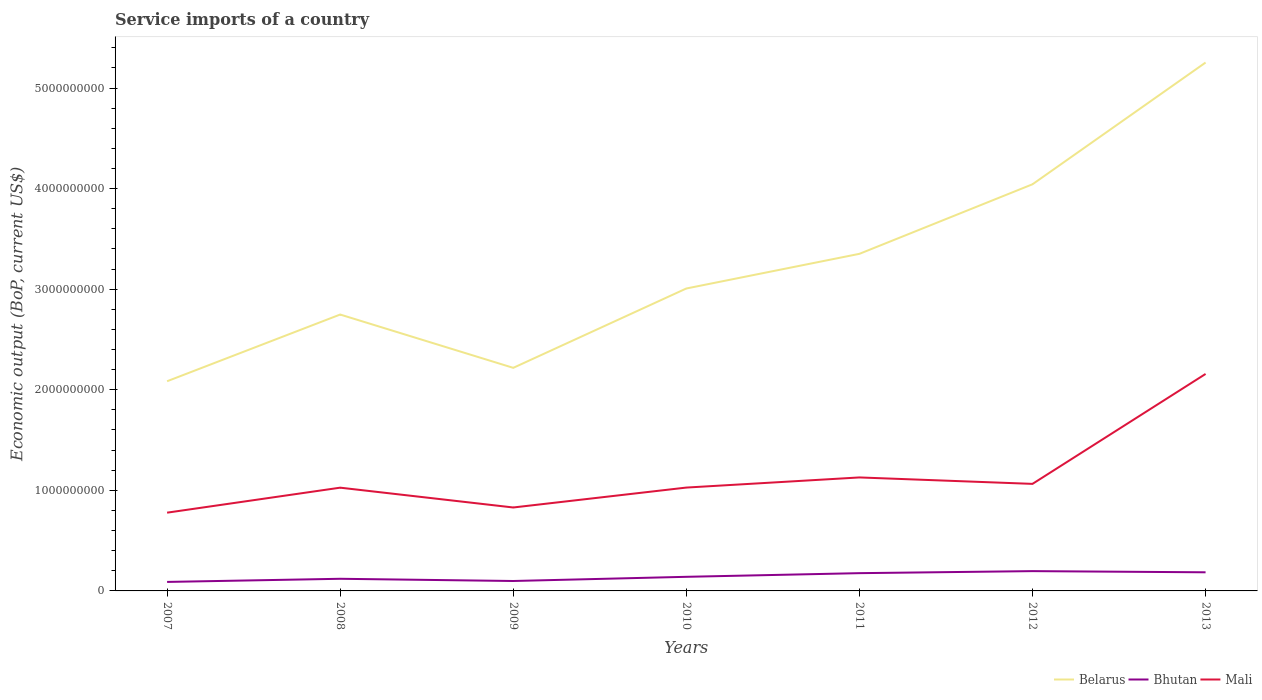Across all years, what is the maximum service imports in Belarus?
Your answer should be very brief. 2.08e+09. In which year was the service imports in Mali maximum?
Your answer should be very brief. 2007. What is the total service imports in Mali in the graph?
Provide a succinct answer. -1.13e+09. What is the difference between the highest and the second highest service imports in Bhutan?
Provide a short and direct response. 1.07e+08. What is the difference between the highest and the lowest service imports in Bhutan?
Ensure brevity in your answer.  3. Is the service imports in Mali strictly greater than the service imports in Bhutan over the years?
Keep it short and to the point. No. Are the values on the major ticks of Y-axis written in scientific E-notation?
Make the answer very short. No. Does the graph contain grids?
Provide a short and direct response. No. Where does the legend appear in the graph?
Ensure brevity in your answer.  Bottom right. How many legend labels are there?
Your answer should be very brief. 3. What is the title of the graph?
Provide a succinct answer. Service imports of a country. Does "Sub-Saharan Africa (all income levels)" appear as one of the legend labels in the graph?
Offer a terse response. No. What is the label or title of the X-axis?
Your answer should be very brief. Years. What is the label or title of the Y-axis?
Make the answer very short. Economic output (BoP, current US$). What is the Economic output (BoP, current US$) in Belarus in 2007?
Keep it short and to the point. 2.08e+09. What is the Economic output (BoP, current US$) of Bhutan in 2007?
Your response must be concise. 8.94e+07. What is the Economic output (BoP, current US$) in Mali in 2007?
Provide a succinct answer. 7.78e+08. What is the Economic output (BoP, current US$) in Belarus in 2008?
Make the answer very short. 2.75e+09. What is the Economic output (BoP, current US$) of Bhutan in 2008?
Provide a short and direct response. 1.21e+08. What is the Economic output (BoP, current US$) of Mali in 2008?
Make the answer very short. 1.03e+09. What is the Economic output (BoP, current US$) in Belarus in 2009?
Make the answer very short. 2.22e+09. What is the Economic output (BoP, current US$) in Bhutan in 2009?
Make the answer very short. 9.87e+07. What is the Economic output (BoP, current US$) of Mali in 2009?
Provide a short and direct response. 8.30e+08. What is the Economic output (BoP, current US$) in Belarus in 2010?
Offer a terse response. 3.01e+09. What is the Economic output (BoP, current US$) in Bhutan in 2010?
Your answer should be compact. 1.40e+08. What is the Economic output (BoP, current US$) in Mali in 2010?
Your answer should be compact. 1.03e+09. What is the Economic output (BoP, current US$) of Belarus in 2011?
Offer a terse response. 3.35e+09. What is the Economic output (BoP, current US$) of Bhutan in 2011?
Provide a short and direct response. 1.77e+08. What is the Economic output (BoP, current US$) in Mali in 2011?
Your answer should be very brief. 1.13e+09. What is the Economic output (BoP, current US$) in Belarus in 2012?
Provide a succinct answer. 4.04e+09. What is the Economic output (BoP, current US$) in Bhutan in 2012?
Keep it short and to the point. 1.97e+08. What is the Economic output (BoP, current US$) of Mali in 2012?
Keep it short and to the point. 1.06e+09. What is the Economic output (BoP, current US$) in Belarus in 2013?
Provide a short and direct response. 5.25e+09. What is the Economic output (BoP, current US$) in Bhutan in 2013?
Give a very brief answer. 1.85e+08. What is the Economic output (BoP, current US$) of Mali in 2013?
Your response must be concise. 2.16e+09. Across all years, what is the maximum Economic output (BoP, current US$) in Belarus?
Offer a very short reply. 5.25e+09. Across all years, what is the maximum Economic output (BoP, current US$) in Bhutan?
Your response must be concise. 1.97e+08. Across all years, what is the maximum Economic output (BoP, current US$) in Mali?
Keep it short and to the point. 2.16e+09. Across all years, what is the minimum Economic output (BoP, current US$) in Belarus?
Your answer should be very brief. 2.08e+09. Across all years, what is the minimum Economic output (BoP, current US$) of Bhutan?
Provide a short and direct response. 8.94e+07. Across all years, what is the minimum Economic output (BoP, current US$) of Mali?
Give a very brief answer. 7.78e+08. What is the total Economic output (BoP, current US$) of Belarus in the graph?
Offer a terse response. 2.27e+1. What is the total Economic output (BoP, current US$) in Bhutan in the graph?
Your answer should be very brief. 1.01e+09. What is the total Economic output (BoP, current US$) in Mali in the graph?
Offer a terse response. 8.01e+09. What is the difference between the Economic output (BoP, current US$) of Belarus in 2007 and that in 2008?
Your response must be concise. -6.63e+08. What is the difference between the Economic output (BoP, current US$) in Bhutan in 2007 and that in 2008?
Your response must be concise. -3.13e+07. What is the difference between the Economic output (BoP, current US$) in Mali in 2007 and that in 2008?
Ensure brevity in your answer.  -2.48e+08. What is the difference between the Economic output (BoP, current US$) in Belarus in 2007 and that in 2009?
Provide a succinct answer. -1.33e+08. What is the difference between the Economic output (BoP, current US$) in Bhutan in 2007 and that in 2009?
Make the answer very short. -9.28e+06. What is the difference between the Economic output (BoP, current US$) of Mali in 2007 and that in 2009?
Offer a terse response. -5.15e+07. What is the difference between the Economic output (BoP, current US$) in Belarus in 2007 and that in 2010?
Provide a short and direct response. -9.22e+08. What is the difference between the Economic output (BoP, current US$) of Bhutan in 2007 and that in 2010?
Offer a terse response. -5.08e+07. What is the difference between the Economic output (BoP, current US$) of Mali in 2007 and that in 2010?
Ensure brevity in your answer.  -2.49e+08. What is the difference between the Economic output (BoP, current US$) of Belarus in 2007 and that in 2011?
Provide a short and direct response. -1.27e+09. What is the difference between the Economic output (BoP, current US$) in Bhutan in 2007 and that in 2011?
Provide a succinct answer. -8.71e+07. What is the difference between the Economic output (BoP, current US$) of Mali in 2007 and that in 2011?
Your answer should be very brief. -3.50e+08. What is the difference between the Economic output (BoP, current US$) in Belarus in 2007 and that in 2012?
Give a very brief answer. -1.96e+09. What is the difference between the Economic output (BoP, current US$) of Bhutan in 2007 and that in 2012?
Your answer should be compact. -1.07e+08. What is the difference between the Economic output (BoP, current US$) in Mali in 2007 and that in 2012?
Give a very brief answer. -2.86e+08. What is the difference between the Economic output (BoP, current US$) of Belarus in 2007 and that in 2013?
Your answer should be compact. -3.17e+09. What is the difference between the Economic output (BoP, current US$) in Bhutan in 2007 and that in 2013?
Make the answer very short. -9.58e+07. What is the difference between the Economic output (BoP, current US$) of Mali in 2007 and that in 2013?
Offer a very short reply. -1.38e+09. What is the difference between the Economic output (BoP, current US$) in Belarus in 2008 and that in 2009?
Offer a terse response. 5.30e+08. What is the difference between the Economic output (BoP, current US$) in Bhutan in 2008 and that in 2009?
Your answer should be compact. 2.20e+07. What is the difference between the Economic output (BoP, current US$) of Mali in 2008 and that in 2009?
Keep it short and to the point. 1.97e+08. What is the difference between the Economic output (BoP, current US$) of Belarus in 2008 and that in 2010?
Provide a succinct answer. -2.59e+08. What is the difference between the Economic output (BoP, current US$) in Bhutan in 2008 and that in 2010?
Provide a succinct answer. -1.95e+07. What is the difference between the Economic output (BoP, current US$) in Mali in 2008 and that in 2010?
Your response must be concise. -1.00e+06. What is the difference between the Economic output (BoP, current US$) of Belarus in 2008 and that in 2011?
Provide a succinct answer. -6.04e+08. What is the difference between the Economic output (BoP, current US$) of Bhutan in 2008 and that in 2011?
Make the answer very short. -5.59e+07. What is the difference between the Economic output (BoP, current US$) in Mali in 2008 and that in 2011?
Your response must be concise. -1.02e+08. What is the difference between the Economic output (BoP, current US$) in Belarus in 2008 and that in 2012?
Provide a succinct answer. -1.30e+09. What is the difference between the Economic output (BoP, current US$) of Bhutan in 2008 and that in 2012?
Your response must be concise. -7.62e+07. What is the difference between the Economic output (BoP, current US$) of Mali in 2008 and that in 2012?
Provide a short and direct response. -3.77e+07. What is the difference between the Economic output (BoP, current US$) in Belarus in 2008 and that in 2013?
Your response must be concise. -2.51e+09. What is the difference between the Economic output (BoP, current US$) of Bhutan in 2008 and that in 2013?
Give a very brief answer. -6.46e+07. What is the difference between the Economic output (BoP, current US$) of Mali in 2008 and that in 2013?
Your answer should be compact. -1.13e+09. What is the difference between the Economic output (BoP, current US$) of Belarus in 2009 and that in 2010?
Provide a short and direct response. -7.89e+08. What is the difference between the Economic output (BoP, current US$) of Bhutan in 2009 and that in 2010?
Your response must be concise. -4.15e+07. What is the difference between the Economic output (BoP, current US$) in Mali in 2009 and that in 2010?
Offer a very short reply. -1.98e+08. What is the difference between the Economic output (BoP, current US$) in Belarus in 2009 and that in 2011?
Provide a succinct answer. -1.13e+09. What is the difference between the Economic output (BoP, current US$) in Bhutan in 2009 and that in 2011?
Ensure brevity in your answer.  -7.79e+07. What is the difference between the Economic output (BoP, current US$) of Mali in 2009 and that in 2011?
Give a very brief answer. -2.99e+08. What is the difference between the Economic output (BoP, current US$) of Belarus in 2009 and that in 2012?
Offer a terse response. -1.83e+09. What is the difference between the Economic output (BoP, current US$) in Bhutan in 2009 and that in 2012?
Offer a terse response. -9.82e+07. What is the difference between the Economic output (BoP, current US$) of Mali in 2009 and that in 2012?
Ensure brevity in your answer.  -2.35e+08. What is the difference between the Economic output (BoP, current US$) in Belarus in 2009 and that in 2013?
Offer a very short reply. -3.04e+09. What is the difference between the Economic output (BoP, current US$) in Bhutan in 2009 and that in 2013?
Offer a terse response. -8.65e+07. What is the difference between the Economic output (BoP, current US$) in Mali in 2009 and that in 2013?
Ensure brevity in your answer.  -1.33e+09. What is the difference between the Economic output (BoP, current US$) in Belarus in 2010 and that in 2011?
Provide a succinct answer. -3.45e+08. What is the difference between the Economic output (BoP, current US$) of Bhutan in 2010 and that in 2011?
Make the answer very short. -3.64e+07. What is the difference between the Economic output (BoP, current US$) in Mali in 2010 and that in 2011?
Your answer should be very brief. -1.01e+08. What is the difference between the Economic output (BoP, current US$) of Belarus in 2010 and that in 2012?
Your answer should be very brief. -1.04e+09. What is the difference between the Economic output (BoP, current US$) of Bhutan in 2010 and that in 2012?
Your response must be concise. -5.67e+07. What is the difference between the Economic output (BoP, current US$) of Mali in 2010 and that in 2012?
Provide a short and direct response. -3.67e+07. What is the difference between the Economic output (BoP, current US$) in Belarus in 2010 and that in 2013?
Give a very brief answer. -2.25e+09. What is the difference between the Economic output (BoP, current US$) in Bhutan in 2010 and that in 2013?
Provide a short and direct response. -4.50e+07. What is the difference between the Economic output (BoP, current US$) of Mali in 2010 and that in 2013?
Your response must be concise. -1.13e+09. What is the difference between the Economic output (BoP, current US$) of Belarus in 2011 and that in 2012?
Your response must be concise. -6.92e+08. What is the difference between the Economic output (BoP, current US$) in Bhutan in 2011 and that in 2012?
Make the answer very short. -2.03e+07. What is the difference between the Economic output (BoP, current US$) of Mali in 2011 and that in 2012?
Your answer should be very brief. 6.41e+07. What is the difference between the Economic output (BoP, current US$) of Belarus in 2011 and that in 2013?
Make the answer very short. -1.90e+09. What is the difference between the Economic output (BoP, current US$) in Bhutan in 2011 and that in 2013?
Ensure brevity in your answer.  -8.68e+06. What is the difference between the Economic output (BoP, current US$) of Mali in 2011 and that in 2013?
Ensure brevity in your answer.  -1.03e+09. What is the difference between the Economic output (BoP, current US$) in Belarus in 2012 and that in 2013?
Ensure brevity in your answer.  -1.21e+09. What is the difference between the Economic output (BoP, current US$) in Bhutan in 2012 and that in 2013?
Keep it short and to the point. 1.16e+07. What is the difference between the Economic output (BoP, current US$) of Mali in 2012 and that in 2013?
Ensure brevity in your answer.  -1.09e+09. What is the difference between the Economic output (BoP, current US$) of Belarus in 2007 and the Economic output (BoP, current US$) of Bhutan in 2008?
Give a very brief answer. 1.96e+09. What is the difference between the Economic output (BoP, current US$) in Belarus in 2007 and the Economic output (BoP, current US$) in Mali in 2008?
Ensure brevity in your answer.  1.06e+09. What is the difference between the Economic output (BoP, current US$) of Bhutan in 2007 and the Economic output (BoP, current US$) of Mali in 2008?
Your answer should be very brief. -9.37e+08. What is the difference between the Economic output (BoP, current US$) of Belarus in 2007 and the Economic output (BoP, current US$) of Bhutan in 2009?
Offer a terse response. 1.99e+09. What is the difference between the Economic output (BoP, current US$) of Belarus in 2007 and the Economic output (BoP, current US$) of Mali in 2009?
Give a very brief answer. 1.26e+09. What is the difference between the Economic output (BoP, current US$) of Bhutan in 2007 and the Economic output (BoP, current US$) of Mali in 2009?
Provide a short and direct response. -7.40e+08. What is the difference between the Economic output (BoP, current US$) in Belarus in 2007 and the Economic output (BoP, current US$) in Bhutan in 2010?
Your answer should be compact. 1.94e+09. What is the difference between the Economic output (BoP, current US$) in Belarus in 2007 and the Economic output (BoP, current US$) in Mali in 2010?
Offer a very short reply. 1.06e+09. What is the difference between the Economic output (BoP, current US$) in Bhutan in 2007 and the Economic output (BoP, current US$) in Mali in 2010?
Your response must be concise. -9.38e+08. What is the difference between the Economic output (BoP, current US$) in Belarus in 2007 and the Economic output (BoP, current US$) in Bhutan in 2011?
Ensure brevity in your answer.  1.91e+09. What is the difference between the Economic output (BoP, current US$) in Belarus in 2007 and the Economic output (BoP, current US$) in Mali in 2011?
Your answer should be compact. 9.56e+08. What is the difference between the Economic output (BoP, current US$) in Bhutan in 2007 and the Economic output (BoP, current US$) in Mali in 2011?
Make the answer very short. -1.04e+09. What is the difference between the Economic output (BoP, current US$) of Belarus in 2007 and the Economic output (BoP, current US$) of Bhutan in 2012?
Ensure brevity in your answer.  1.89e+09. What is the difference between the Economic output (BoP, current US$) in Belarus in 2007 and the Economic output (BoP, current US$) in Mali in 2012?
Offer a very short reply. 1.02e+09. What is the difference between the Economic output (BoP, current US$) in Bhutan in 2007 and the Economic output (BoP, current US$) in Mali in 2012?
Ensure brevity in your answer.  -9.75e+08. What is the difference between the Economic output (BoP, current US$) in Belarus in 2007 and the Economic output (BoP, current US$) in Bhutan in 2013?
Your answer should be compact. 1.90e+09. What is the difference between the Economic output (BoP, current US$) of Belarus in 2007 and the Economic output (BoP, current US$) of Mali in 2013?
Provide a short and direct response. -7.26e+07. What is the difference between the Economic output (BoP, current US$) of Bhutan in 2007 and the Economic output (BoP, current US$) of Mali in 2013?
Provide a succinct answer. -2.07e+09. What is the difference between the Economic output (BoP, current US$) of Belarus in 2008 and the Economic output (BoP, current US$) of Bhutan in 2009?
Give a very brief answer. 2.65e+09. What is the difference between the Economic output (BoP, current US$) of Belarus in 2008 and the Economic output (BoP, current US$) of Mali in 2009?
Your answer should be compact. 1.92e+09. What is the difference between the Economic output (BoP, current US$) of Bhutan in 2008 and the Economic output (BoP, current US$) of Mali in 2009?
Provide a succinct answer. -7.09e+08. What is the difference between the Economic output (BoP, current US$) of Belarus in 2008 and the Economic output (BoP, current US$) of Bhutan in 2010?
Your answer should be compact. 2.61e+09. What is the difference between the Economic output (BoP, current US$) of Belarus in 2008 and the Economic output (BoP, current US$) of Mali in 2010?
Ensure brevity in your answer.  1.72e+09. What is the difference between the Economic output (BoP, current US$) of Bhutan in 2008 and the Economic output (BoP, current US$) of Mali in 2010?
Make the answer very short. -9.07e+08. What is the difference between the Economic output (BoP, current US$) in Belarus in 2008 and the Economic output (BoP, current US$) in Bhutan in 2011?
Offer a terse response. 2.57e+09. What is the difference between the Economic output (BoP, current US$) in Belarus in 2008 and the Economic output (BoP, current US$) in Mali in 2011?
Ensure brevity in your answer.  1.62e+09. What is the difference between the Economic output (BoP, current US$) in Bhutan in 2008 and the Economic output (BoP, current US$) in Mali in 2011?
Offer a terse response. -1.01e+09. What is the difference between the Economic output (BoP, current US$) of Belarus in 2008 and the Economic output (BoP, current US$) of Bhutan in 2012?
Your response must be concise. 2.55e+09. What is the difference between the Economic output (BoP, current US$) in Belarus in 2008 and the Economic output (BoP, current US$) in Mali in 2012?
Provide a short and direct response. 1.68e+09. What is the difference between the Economic output (BoP, current US$) in Bhutan in 2008 and the Economic output (BoP, current US$) in Mali in 2012?
Give a very brief answer. -9.44e+08. What is the difference between the Economic output (BoP, current US$) in Belarus in 2008 and the Economic output (BoP, current US$) in Bhutan in 2013?
Keep it short and to the point. 2.56e+09. What is the difference between the Economic output (BoP, current US$) of Belarus in 2008 and the Economic output (BoP, current US$) of Mali in 2013?
Make the answer very short. 5.91e+08. What is the difference between the Economic output (BoP, current US$) of Bhutan in 2008 and the Economic output (BoP, current US$) of Mali in 2013?
Offer a very short reply. -2.04e+09. What is the difference between the Economic output (BoP, current US$) of Belarus in 2009 and the Economic output (BoP, current US$) of Bhutan in 2010?
Your answer should be compact. 2.08e+09. What is the difference between the Economic output (BoP, current US$) of Belarus in 2009 and the Economic output (BoP, current US$) of Mali in 2010?
Your answer should be very brief. 1.19e+09. What is the difference between the Economic output (BoP, current US$) of Bhutan in 2009 and the Economic output (BoP, current US$) of Mali in 2010?
Give a very brief answer. -9.29e+08. What is the difference between the Economic output (BoP, current US$) in Belarus in 2009 and the Economic output (BoP, current US$) in Bhutan in 2011?
Ensure brevity in your answer.  2.04e+09. What is the difference between the Economic output (BoP, current US$) of Belarus in 2009 and the Economic output (BoP, current US$) of Mali in 2011?
Provide a succinct answer. 1.09e+09. What is the difference between the Economic output (BoP, current US$) in Bhutan in 2009 and the Economic output (BoP, current US$) in Mali in 2011?
Offer a very short reply. -1.03e+09. What is the difference between the Economic output (BoP, current US$) in Belarus in 2009 and the Economic output (BoP, current US$) in Bhutan in 2012?
Offer a very short reply. 2.02e+09. What is the difference between the Economic output (BoP, current US$) in Belarus in 2009 and the Economic output (BoP, current US$) in Mali in 2012?
Your answer should be very brief. 1.15e+09. What is the difference between the Economic output (BoP, current US$) of Bhutan in 2009 and the Economic output (BoP, current US$) of Mali in 2012?
Offer a very short reply. -9.66e+08. What is the difference between the Economic output (BoP, current US$) of Belarus in 2009 and the Economic output (BoP, current US$) of Bhutan in 2013?
Provide a succinct answer. 2.03e+09. What is the difference between the Economic output (BoP, current US$) of Belarus in 2009 and the Economic output (BoP, current US$) of Mali in 2013?
Offer a terse response. 6.06e+07. What is the difference between the Economic output (BoP, current US$) in Bhutan in 2009 and the Economic output (BoP, current US$) in Mali in 2013?
Your answer should be compact. -2.06e+09. What is the difference between the Economic output (BoP, current US$) of Belarus in 2010 and the Economic output (BoP, current US$) of Bhutan in 2011?
Give a very brief answer. 2.83e+09. What is the difference between the Economic output (BoP, current US$) in Belarus in 2010 and the Economic output (BoP, current US$) in Mali in 2011?
Offer a very short reply. 1.88e+09. What is the difference between the Economic output (BoP, current US$) in Bhutan in 2010 and the Economic output (BoP, current US$) in Mali in 2011?
Provide a short and direct response. -9.88e+08. What is the difference between the Economic output (BoP, current US$) in Belarus in 2010 and the Economic output (BoP, current US$) in Bhutan in 2012?
Offer a very short reply. 2.81e+09. What is the difference between the Economic output (BoP, current US$) in Belarus in 2010 and the Economic output (BoP, current US$) in Mali in 2012?
Your answer should be compact. 1.94e+09. What is the difference between the Economic output (BoP, current US$) in Bhutan in 2010 and the Economic output (BoP, current US$) in Mali in 2012?
Give a very brief answer. -9.24e+08. What is the difference between the Economic output (BoP, current US$) in Belarus in 2010 and the Economic output (BoP, current US$) in Bhutan in 2013?
Offer a very short reply. 2.82e+09. What is the difference between the Economic output (BoP, current US$) in Belarus in 2010 and the Economic output (BoP, current US$) in Mali in 2013?
Your response must be concise. 8.50e+08. What is the difference between the Economic output (BoP, current US$) of Bhutan in 2010 and the Economic output (BoP, current US$) of Mali in 2013?
Offer a very short reply. -2.02e+09. What is the difference between the Economic output (BoP, current US$) in Belarus in 2011 and the Economic output (BoP, current US$) in Bhutan in 2012?
Provide a short and direct response. 3.15e+09. What is the difference between the Economic output (BoP, current US$) of Belarus in 2011 and the Economic output (BoP, current US$) of Mali in 2012?
Keep it short and to the point. 2.29e+09. What is the difference between the Economic output (BoP, current US$) of Bhutan in 2011 and the Economic output (BoP, current US$) of Mali in 2012?
Offer a terse response. -8.88e+08. What is the difference between the Economic output (BoP, current US$) in Belarus in 2011 and the Economic output (BoP, current US$) in Bhutan in 2013?
Offer a terse response. 3.17e+09. What is the difference between the Economic output (BoP, current US$) in Belarus in 2011 and the Economic output (BoP, current US$) in Mali in 2013?
Provide a succinct answer. 1.19e+09. What is the difference between the Economic output (BoP, current US$) in Bhutan in 2011 and the Economic output (BoP, current US$) in Mali in 2013?
Provide a succinct answer. -1.98e+09. What is the difference between the Economic output (BoP, current US$) in Belarus in 2012 and the Economic output (BoP, current US$) in Bhutan in 2013?
Offer a terse response. 3.86e+09. What is the difference between the Economic output (BoP, current US$) in Belarus in 2012 and the Economic output (BoP, current US$) in Mali in 2013?
Give a very brief answer. 1.89e+09. What is the difference between the Economic output (BoP, current US$) in Bhutan in 2012 and the Economic output (BoP, current US$) in Mali in 2013?
Give a very brief answer. -1.96e+09. What is the average Economic output (BoP, current US$) of Belarus per year?
Make the answer very short. 3.24e+09. What is the average Economic output (BoP, current US$) of Bhutan per year?
Provide a short and direct response. 1.44e+08. What is the average Economic output (BoP, current US$) of Mali per year?
Keep it short and to the point. 1.14e+09. In the year 2007, what is the difference between the Economic output (BoP, current US$) of Belarus and Economic output (BoP, current US$) of Bhutan?
Your answer should be very brief. 2.00e+09. In the year 2007, what is the difference between the Economic output (BoP, current US$) of Belarus and Economic output (BoP, current US$) of Mali?
Make the answer very short. 1.31e+09. In the year 2007, what is the difference between the Economic output (BoP, current US$) of Bhutan and Economic output (BoP, current US$) of Mali?
Provide a short and direct response. -6.89e+08. In the year 2008, what is the difference between the Economic output (BoP, current US$) in Belarus and Economic output (BoP, current US$) in Bhutan?
Provide a succinct answer. 2.63e+09. In the year 2008, what is the difference between the Economic output (BoP, current US$) of Belarus and Economic output (BoP, current US$) of Mali?
Offer a very short reply. 1.72e+09. In the year 2008, what is the difference between the Economic output (BoP, current US$) in Bhutan and Economic output (BoP, current US$) in Mali?
Ensure brevity in your answer.  -9.06e+08. In the year 2009, what is the difference between the Economic output (BoP, current US$) of Belarus and Economic output (BoP, current US$) of Bhutan?
Keep it short and to the point. 2.12e+09. In the year 2009, what is the difference between the Economic output (BoP, current US$) in Belarus and Economic output (BoP, current US$) in Mali?
Provide a short and direct response. 1.39e+09. In the year 2009, what is the difference between the Economic output (BoP, current US$) in Bhutan and Economic output (BoP, current US$) in Mali?
Keep it short and to the point. -7.31e+08. In the year 2010, what is the difference between the Economic output (BoP, current US$) of Belarus and Economic output (BoP, current US$) of Bhutan?
Your answer should be very brief. 2.87e+09. In the year 2010, what is the difference between the Economic output (BoP, current US$) in Belarus and Economic output (BoP, current US$) in Mali?
Your answer should be compact. 1.98e+09. In the year 2010, what is the difference between the Economic output (BoP, current US$) of Bhutan and Economic output (BoP, current US$) of Mali?
Your response must be concise. -8.87e+08. In the year 2011, what is the difference between the Economic output (BoP, current US$) in Belarus and Economic output (BoP, current US$) in Bhutan?
Offer a very short reply. 3.18e+09. In the year 2011, what is the difference between the Economic output (BoP, current US$) in Belarus and Economic output (BoP, current US$) in Mali?
Your answer should be compact. 2.22e+09. In the year 2011, what is the difference between the Economic output (BoP, current US$) of Bhutan and Economic output (BoP, current US$) of Mali?
Make the answer very short. -9.52e+08. In the year 2012, what is the difference between the Economic output (BoP, current US$) in Belarus and Economic output (BoP, current US$) in Bhutan?
Offer a terse response. 3.85e+09. In the year 2012, what is the difference between the Economic output (BoP, current US$) of Belarus and Economic output (BoP, current US$) of Mali?
Provide a short and direct response. 2.98e+09. In the year 2012, what is the difference between the Economic output (BoP, current US$) in Bhutan and Economic output (BoP, current US$) in Mali?
Provide a succinct answer. -8.67e+08. In the year 2013, what is the difference between the Economic output (BoP, current US$) in Belarus and Economic output (BoP, current US$) in Bhutan?
Your response must be concise. 5.07e+09. In the year 2013, what is the difference between the Economic output (BoP, current US$) in Belarus and Economic output (BoP, current US$) in Mali?
Your answer should be very brief. 3.10e+09. In the year 2013, what is the difference between the Economic output (BoP, current US$) of Bhutan and Economic output (BoP, current US$) of Mali?
Ensure brevity in your answer.  -1.97e+09. What is the ratio of the Economic output (BoP, current US$) in Belarus in 2007 to that in 2008?
Keep it short and to the point. 0.76. What is the ratio of the Economic output (BoP, current US$) in Bhutan in 2007 to that in 2008?
Give a very brief answer. 0.74. What is the ratio of the Economic output (BoP, current US$) in Mali in 2007 to that in 2008?
Offer a very short reply. 0.76. What is the ratio of the Economic output (BoP, current US$) in Belarus in 2007 to that in 2009?
Offer a terse response. 0.94. What is the ratio of the Economic output (BoP, current US$) of Bhutan in 2007 to that in 2009?
Offer a very short reply. 0.91. What is the ratio of the Economic output (BoP, current US$) of Mali in 2007 to that in 2009?
Offer a terse response. 0.94. What is the ratio of the Economic output (BoP, current US$) in Belarus in 2007 to that in 2010?
Offer a terse response. 0.69. What is the ratio of the Economic output (BoP, current US$) of Bhutan in 2007 to that in 2010?
Provide a short and direct response. 0.64. What is the ratio of the Economic output (BoP, current US$) in Mali in 2007 to that in 2010?
Your answer should be very brief. 0.76. What is the ratio of the Economic output (BoP, current US$) of Belarus in 2007 to that in 2011?
Offer a terse response. 0.62. What is the ratio of the Economic output (BoP, current US$) in Bhutan in 2007 to that in 2011?
Give a very brief answer. 0.51. What is the ratio of the Economic output (BoP, current US$) of Mali in 2007 to that in 2011?
Provide a short and direct response. 0.69. What is the ratio of the Economic output (BoP, current US$) of Belarus in 2007 to that in 2012?
Keep it short and to the point. 0.52. What is the ratio of the Economic output (BoP, current US$) of Bhutan in 2007 to that in 2012?
Offer a terse response. 0.45. What is the ratio of the Economic output (BoP, current US$) in Mali in 2007 to that in 2012?
Offer a very short reply. 0.73. What is the ratio of the Economic output (BoP, current US$) in Belarus in 2007 to that in 2013?
Provide a succinct answer. 0.4. What is the ratio of the Economic output (BoP, current US$) of Bhutan in 2007 to that in 2013?
Give a very brief answer. 0.48. What is the ratio of the Economic output (BoP, current US$) of Mali in 2007 to that in 2013?
Make the answer very short. 0.36. What is the ratio of the Economic output (BoP, current US$) in Belarus in 2008 to that in 2009?
Offer a terse response. 1.24. What is the ratio of the Economic output (BoP, current US$) in Bhutan in 2008 to that in 2009?
Make the answer very short. 1.22. What is the ratio of the Economic output (BoP, current US$) in Mali in 2008 to that in 2009?
Keep it short and to the point. 1.24. What is the ratio of the Economic output (BoP, current US$) in Belarus in 2008 to that in 2010?
Provide a short and direct response. 0.91. What is the ratio of the Economic output (BoP, current US$) of Bhutan in 2008 to that in 2010?
Your response must be concise. 0.86. What is the ratio of the Economic output (BoP, current US$) in Mali in 2008 to that in 2010?
Make the answer very short. 1. What is the ratio of the Economic output (BoP, current US$) in Belarus in 2008 to that in 2011?
Ensure brevity in your answer.  0.82. What is the ratio of the Economic output (BoP, current US$) of Bhutan in 2008 to that in 2011?
Make the answer very short. 0.68. What is the ratio of the Economic output (BoP, current US$) in Mali in 2008 to that in 2011?
Provide a succinct answer. 0.91. What is the ratio of the Economic output (BoP, current US$) of Belarus in 2008 to that in 2012?
Provide a short and direct response. 0.68. What is the ratio of the Economic output (BoP, current US$) in Bhutan in 2008 to that in 2012?
Provide a short and direct response. 0.61. What is the ratio of the Economic output (BoP, current US$) of Mali in 2008 to that in 2012?
Provide a short and direct response. 0.96. What is the ratio of the Economic output (BoP, current US$) in Belarus in 2008 to that in 2013?
Keep it short and to the point. 0.52. What is the ratio of the Economic output (BoP, current US$) of Bhutan in 2008 to that in 2013?
Provide a succinct answer. 0.65. What is the ratio of the Economic output (BoP, current US$) of Mali in 2008 to that in 2013?
Your response must be concise. 0.48. What is the ratio of the Economic output (BoP, current US$) of Belarus in 2009 to that in 2010?
Ensure brevity in your answer.  0.74. What is the ratio of the Economic output (BoP, current US$) in Bhutan in 2009 to that in 2010?
Provide a short and direct response. 0.7. What is the ratio of the Economic output (BoP, current US$) of Mali in 2009 to that in 2010?
Your answer should be very brief. 0.81. What is the ratio of the Economic output (BoP, current US$) of Belarus in 2009 to that in 2011?
Make the answer very short. 0.66. What is the ratio of the Economic output (BoP, current US$) of Bhutan in 2009 to that in 2011?
Ensure brevity in your answer.  0.56. What is the ratio of the Economic output (BoP, current US$) in Mali in 2009 to that in 2011?
Your answer should be very brief. 0.74. What is the ratio of the Economic output (BoP, current US$) in Belarus in 2009 to that in 2012?
Provide a short and direct response. 0.55. What is the ratio of the Economic output (BoP, current US$) of Bhutan in 2009 to that in 2012?
Keep it short and to the point. 0.5. What is the ratio of the Economic output (BoP, current US$) in Mali in 2009 to that in 2012?
Provide a succinct answer. 0.78. What is the ratio of the Economic output (BoP, current US$) of Belarus in 2009 to that in 2013?
Offer a very short reply. 0.42. What is the ratio of the Economic output (BoP, current US$) of Bhutan in 2009 to that in 2013?
Offer a terse response. 0.53. What is the ratio of the Economic output (BoP, current US$) of Mali in 2009 to that in 2013?
Provide a short and direct response. 0.38. What is the ratio of the Economic output (BoP, current US$) in Belarus in 2010 to that in 2011?
Your answer should be compact. 0.9. What is the ratio of the Economic output (BoP, current US$) in Bhutan in 2010 to that in 2011?
Your answer should be compact. 0.79. What is the ratio of the Economic output (BoP, current US$) of Mali in 2010 to that in 2011?
Your answer should be compact. 0.91. What is the ratio of the Economic output (BoP, current US$) of Belarus in 2010 to that in 2012?
Your response must be concise. 0.74. What is the ratio of the Economic output (BoP, current US$) of Bhutan in 2010 to that in 2012?
Your answer should be very brief. 0.71. What is the ratio of the Economic output (BoP, current US$) in Mali in 2010 to that in 2012?
Provide a short and direct response. 0.97. What is the ratio of the Economic output (BoP, current US$) in Belarus in 2010 to that in 2013?
Provide a succinct answer. 0.57. What is the ratio of the Economic output (BoP, current US$) of Bhutan in 2010 to that in 2013?
Your response must be concise. 0.76. What is the ratio of the Economic output (BoP, current US$) in Mali in 2010 to that in 2013?
Offer a very short reply. 0.48. What is the ratio of the Economic output (BoP, current US$) of Belarus in 2011 to that in 2012?
Make the answer very short. 0.83. What is the ratio of the Economic output (BoP, current US$) in Bhutan in 2011 to that in 2012?
Give a very brief answer. 0.9. What is the ratio of the Economic output (BoP, current US$) of Mali in 2011 to that in 2012?
Provide a succinct answer. 1.06. What is the ratio of the Economic output (BoP, current US$) of Belarus in 2011 to that in 2013?
Offer a terse response. 0.64. What is the ratio of the Economic output (BoP, current US$) in Bhutan in 2011 to that in 2013?
Give a very brief answer. 0.95. What is the ratio of the Economic output (BoP, current US$) in Mali in 2011 to that in 2013?
Your answer should be very brief. 0.52. What is the ratio of the Economic output (BoP, current US$) in Belarus in 2012 to that in 2013?
Your answer should be compact. 0.77. What is the ratio of the Economic output (BoP, current US$) of Bhutan in 2012 to that in 2013?
Keep it short and to the point. 1.06. What is the ratio of the Economic output (BoP, current US$) of Mali in 2012 to that in 2013?
Keep it short and to the point. 0.49. What is the difference between the highest and the second highest Economic output (BoP, current US$) in Belarus?
Give a very brief answer. 1.21e+09. What is the difference between the highest and the second highest Economic output (BoP, current US$) in Bhutan?
Your answer should be very brief. 1.16e+07. What is the difference between the highest and the second highest Economic output (BoP, current US$) in Mali?
Your response must be concise. 1.03e+09. What is the difference between the highest and the lowest Economic output (BoP, current US$) in Belarus?
Make the answer very short. 3.17e+09. What is the difference between the highest and the lowest Economic output (BoP, current US$) in Bhutan?
Your answer should be compact. 1.07e+08. What is the difference between the highest and the lowest Economic output (BoP, current US$) in Mali?
Offer a terse response. 1.38e+09. 